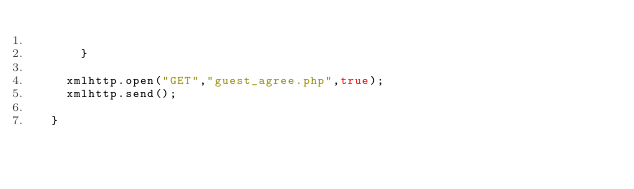Convert code to text. <code><loc_0><loc_0><loc_500><loc_500><_JavaScript_>     
      }
    
    xmlhttp.open("GET","guest_agree.php",true);
    xmlhttp.send();
    
  }</code> 